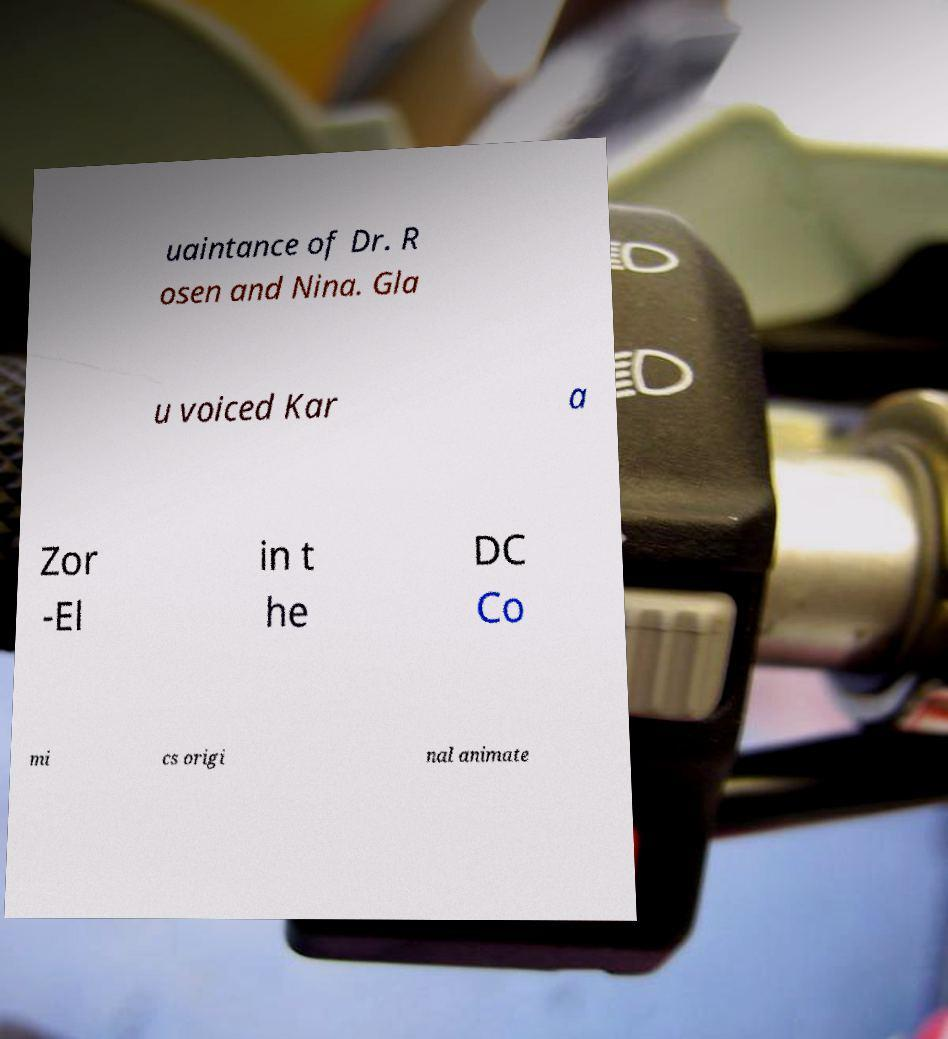Please identify and transcribe the text found in this image. uaintance of Dr. R osen and Nina. Gla u voiced Kar a Zor -El in t he DC Co mi cs origi nal animate 